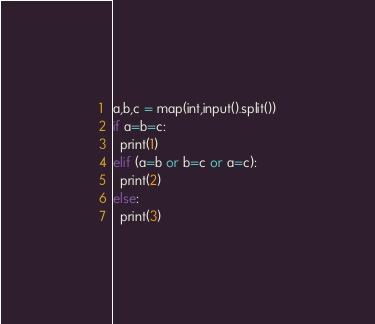<code> <loc_0><loc_0><loc_500><loc_500><_Python_>a,b,c = map(int,input().split())
if a=b=c:
  print(1)
elif (a=b or b=c or a=c):
  print(2)
else:
  print(3)
</code> 